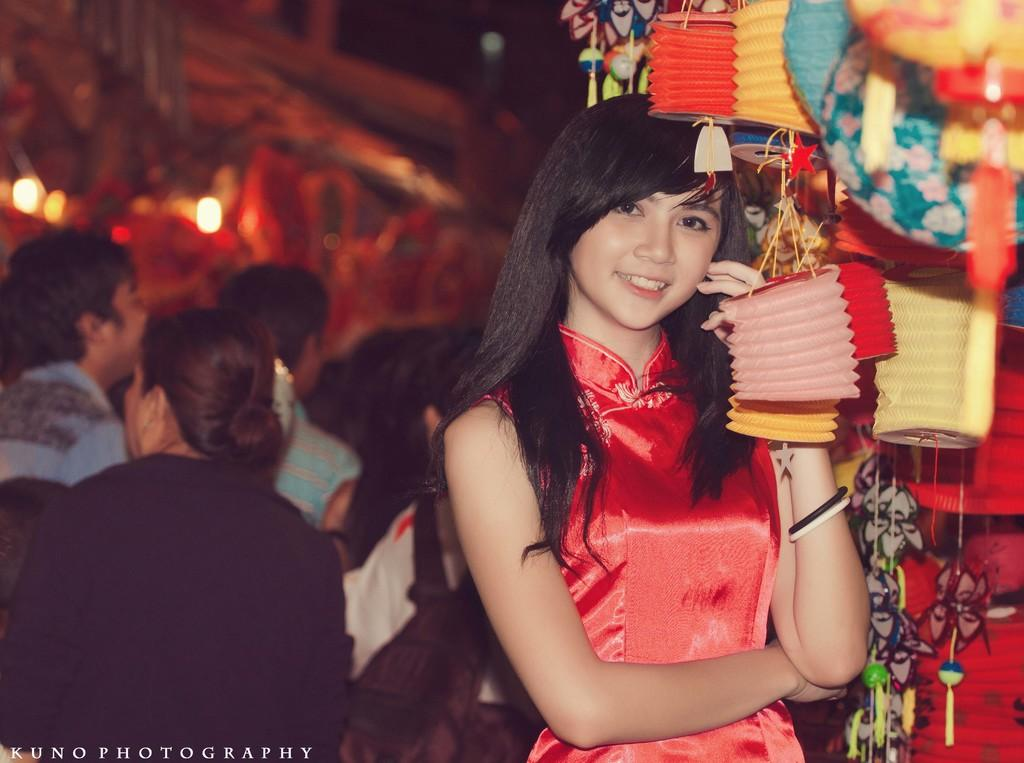What can be seen in the image? There is a group of people in the image. What are the people wearing? The people are wearing clothes. Where are the decorations located in the image? The decorations are in the top right of the image. What language are the people speaking in the image? The image does not provide any information about the language being spoken by the people. Is there a tree visible in the image? There is no tree present in the image. 